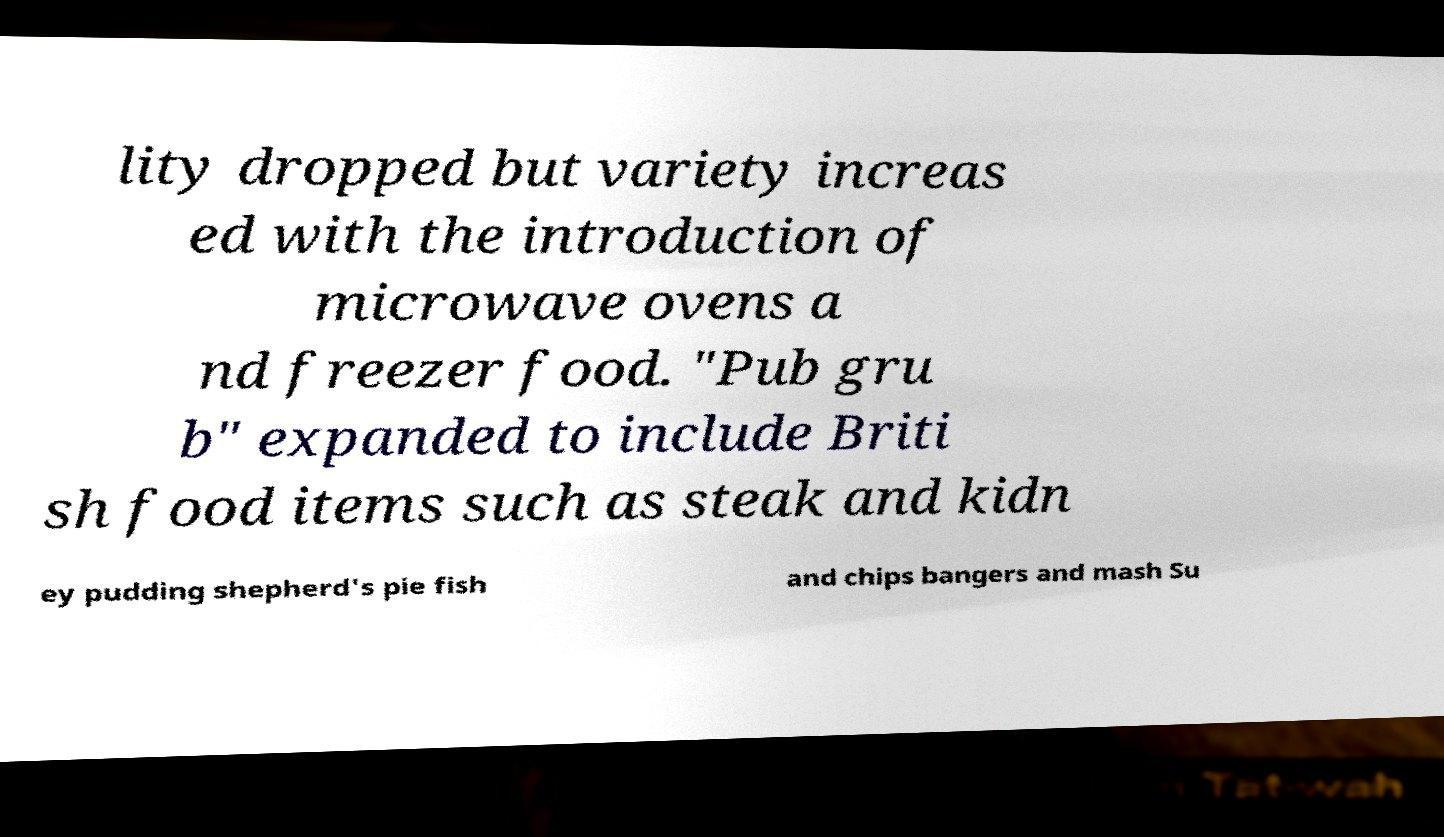I need the written content from this picture converted into text. Can you do that? lity dropped but variety increas ed with the introduction of microwave ovens a nd freezer food. "Pub gru b" expanded to include Briti sh food items such as steak and kidn ey pudding shepherd's pie fish and chips bangers and mash Su 